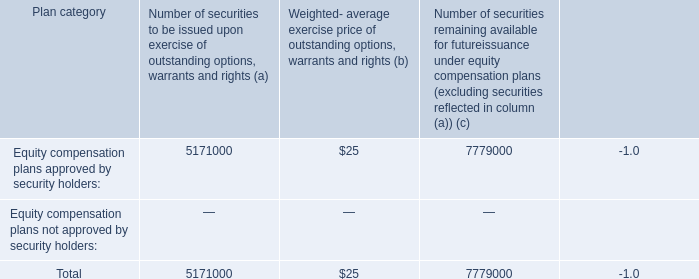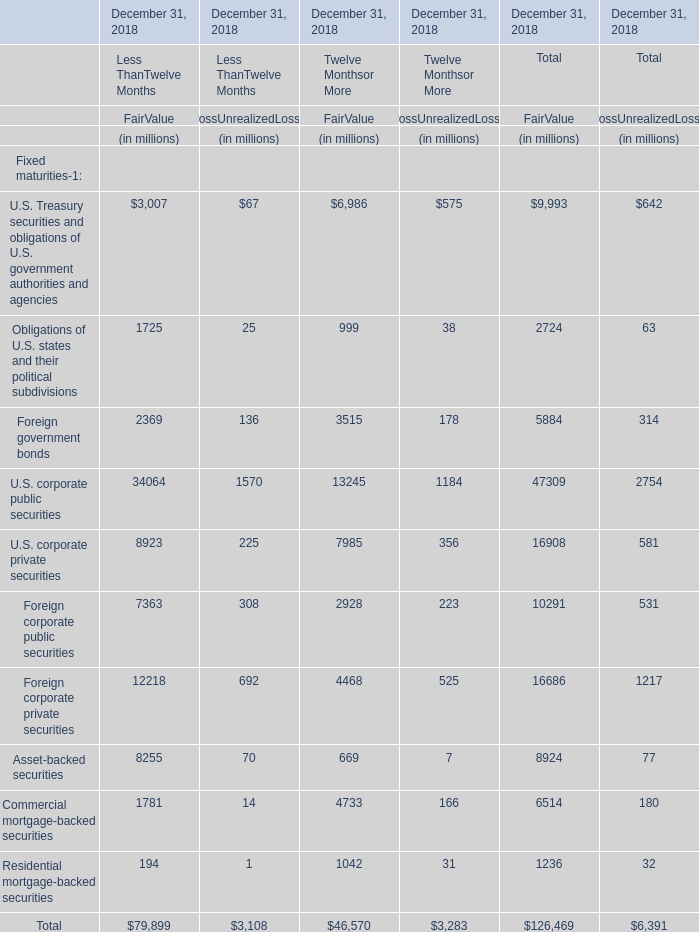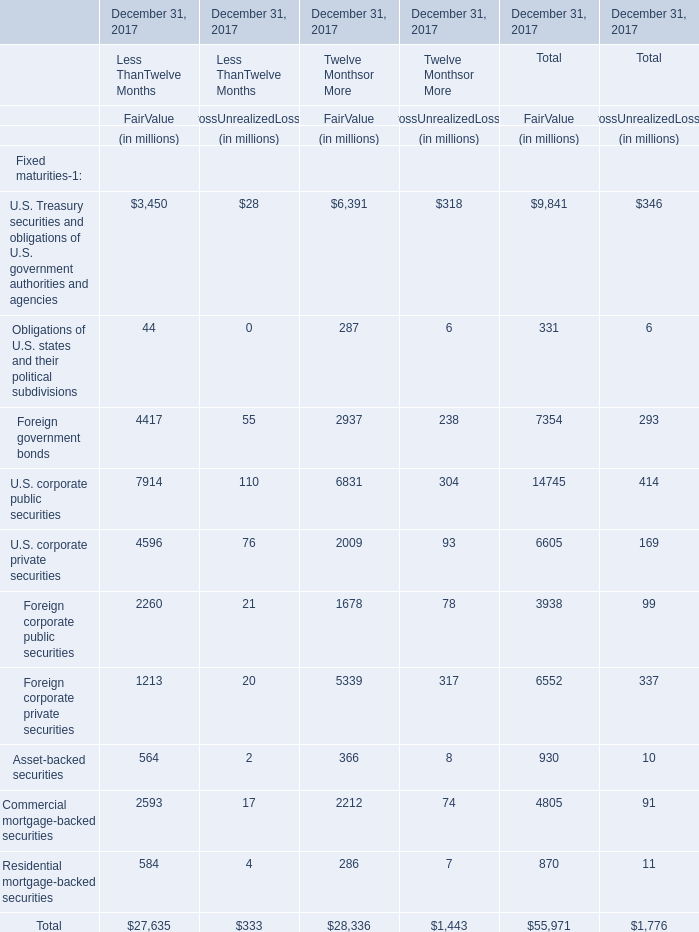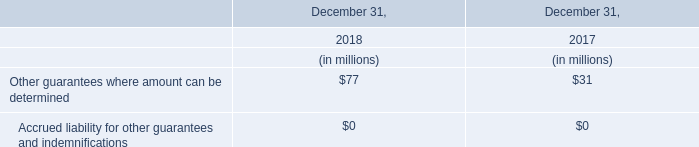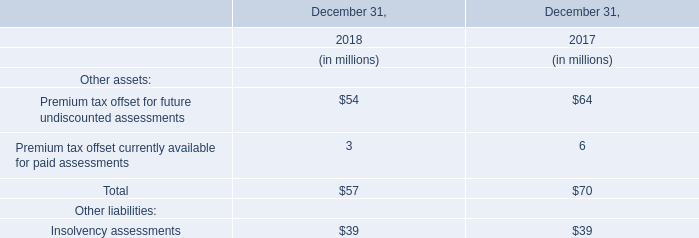What is the proportion of all elements that are greater than 10000 to the total amount of elements, for FairValue of Less ThanTwelve Months? 
Computations: ((34064 + 12218) / 79899)
Answer: 0.57926. 